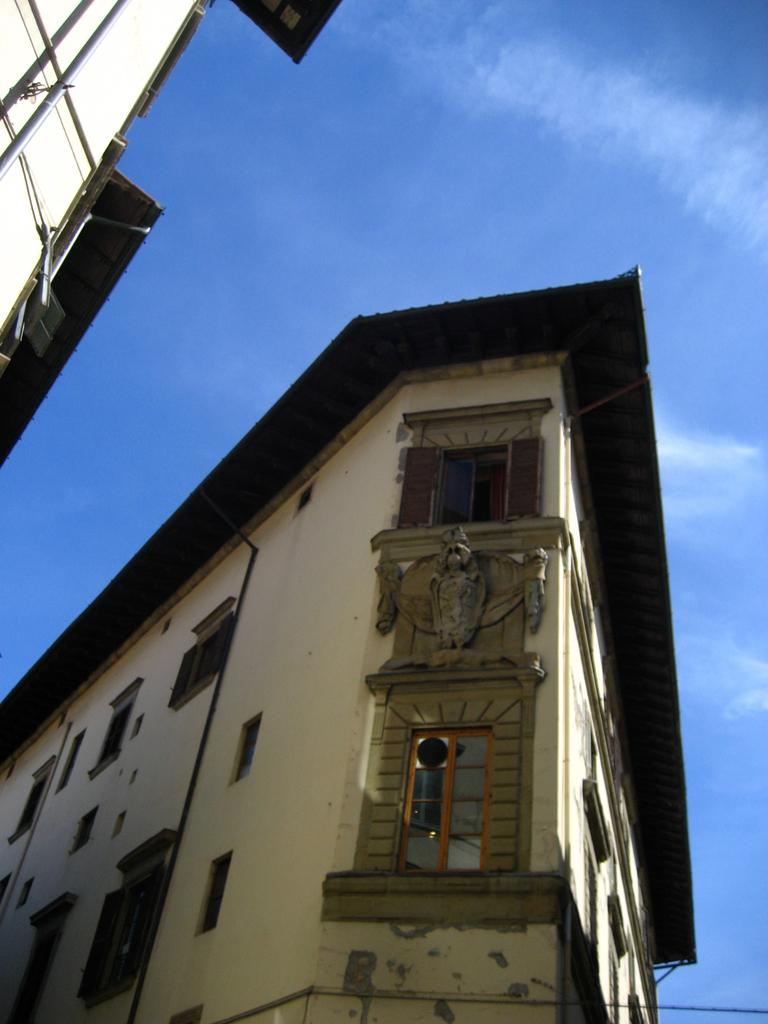What structures are visible in the image? There are buildings in the image. What can be seen in the sky at the top of the image? There are clouds in the sky at the top of the image. What type of list is being discussed by the minister in the image? There is no minister or list present in the image; it only features buildings and clouds. 